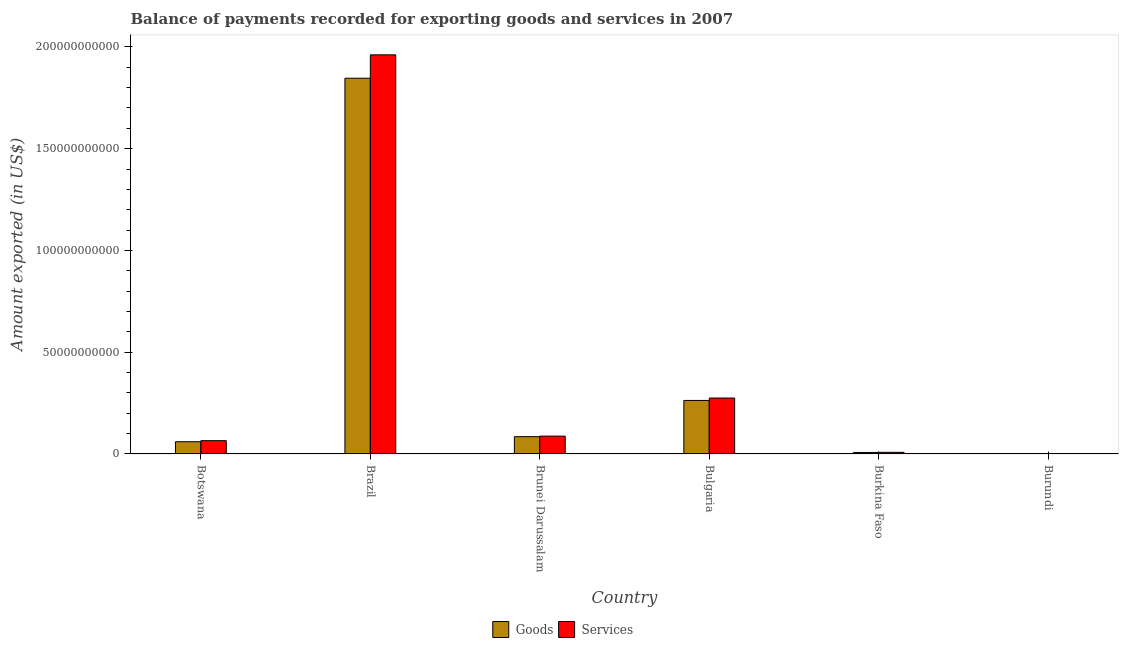How many different coloured bars are there?
Your answer should be very brief. 2. How many groups of bars are there?
Provide a short and direct response. 6. Are the number of bars per tick equal to the number of legend labels?
Keep it short and to the point. Yes. Are the number of bars on each tick of the X-axis equal?
Provide a succinct answer. Yes. In how many cases, is the number of bars for a given country not equal to the number of legend labels?
Make the answer very short. 0. What is the amount of goods exported in Brazil?
Ensure brevity in your answer.  1.85e+11. Across all countries, what is the maximum amount of services exported?
Keep it short and to the point. 1.96e+11. Across all countries, what is the minimum amount of services exported?
Offer a terse response. 9.83e+07. In which country was the amount of goods exported minimum?
Keep it short and to the point. Burundi. What is the total amount of services exported in the graph?
Provide a succinct answer. 2.40e+11. What is the difference between the amount of goods exported in Brunei Darussalam and that in Burkina Faso?
Your response must be concise. 7.76e+09. What is the difference between the amount of goods exported in Brazil and the amount of services exported in Botswana?
Your response must be concise. 1.78e+11. What is the average amount of goods exported per country?
Ensure brevity in your answer.  3.77e+1. What is the difference between the amount of goods exported and amount of services exported in Brazil?
Make the answer very short. -1.15e+1. In how many countries, is the amount of goods exported greater than 170000000000 US$?
Keep it short and to the point. 1. What is the ratio of the amount of goods exported in Botswana to that in Brazil?
Offer a terse response. 0.03. Is the difference between the amount of goods exported in Bulgaria and Burkina Faso greater than the difference between the amount of services exported in Bulgaria and Burkina Faso?
Your answer should be very brief. No. What is the difference between the highest and the second highest amount of goods exported?
Offer a terse response. 1.58e+11. What is the difference between the highest and the lowest amount of goods exported?
Provide a succinct answer. 1.85e+11. Is the sum of the amount of services exported in Botswana and Burkina Faso greater than the maximum amount of goods exported across all countries?
Give a very brief answer. No. What does the 1st bar from the left in Brunei Darussalam represents?
Your answer should be very brief. Goods. What does the 2nd bar from the right in Burundi represents?
Ensure brevity in your answer.  Goods. How many countries are there in the graph?
Offer a terse response. 6. What is the difference between two consecutive major ticks on the Y-axis?
Your answer should be very brief. 5.00e+1. Are the values on the major ticks of Y-axis written in scientific E-notation?
Provide a short and direct response. No. Does the graph contain any zero values?
Your response must be concise. No. How are the legend labels stacked?
Provide a short and direct response. Horizontal. What is the title of the graph?
Offer a very short reply. Balance of payments recorded for exporting goods and services in 2007. Does "Chemicals" appear as one of the legend labels in the graph?
Your answer should be compact. No. What is the label or title of the Y-axis?
Offer a very short reply. Amount exported (in US$). What is the Amount exported (in US$) in Goods in Botswana?
Keep it short and to the point. 6.01e+09. What is the Amount exported (in US$) of Services in Botswana?
Offer a terse response. 6.54e+09. What is the Amount exported (in US$) in Goods in Brazil?
Give a very brief answer. 1.85e+11. What is the Amount exported (in US$) in Services in Brazil?
Offer a terse response. 1.96e+11. What is the Amount exported (in US$) in Goods in Brunei Darussalam?
Provide a succinct answer. 8.50e+09. What is the Amount exported (in US$) of Services in Brunei Darussalam?
Make the answer very short. 8.77e+09. What is the Amount exported (in US$) in Goods in Bulgaria?
Ensure brevity in your answer.  2.63e+1. What is the Amount exported (in US$) in Services in Bulgaria?
Your response must be concise. 2.75e+1. What is the Amount exported (in US$) in Goods in Burkina Faso?
Offer a very short reply. 7.41e+08. What is the Amount exported (in US$) of Services in Burkina Faso?
Offer a terse response. 8.04e+08. What is the Amount exported (in US$) in Goods in Burundi?
Give a very brief answer. 8.96e+07. What is the Amount exported (in US$) of Services in Burundi?
Provide a succinct answer. 9.83e+07. Across all countries, what is the maximum Amount exported (in US$) in Goods?
Your answer should be compact. 1.85e+11. Across all countries, what is the maximum Amount exported (in US$) of Services?
Keep it short and to the point. 1.96e+11. Across all countries, what is the minimum Amount exported (in US$) of Goods?
Your answer should be very brief. 8.96e+07. Across all countries, what is the minimum Amount exported (in US$) of Services?
Ensure brevity in your answer.  9.83e+07. What is the total Amount exported (in US$) of Goods in the graph?
Your response must be concise. 2.26e+11. What is the total Amount exported (in US$) in Services in the graph?
Offer a very short reply. 2.40e+11. What is the difference between the Amount exported (in US$) in Goods in Botswana and that in Brazil?
Offer a very short reply. -1.79e+11. What is the difference between the Amount exported (in US$) in Services in Botswana and that in Brazil?
Ensure brevity in your answer.  -1.90e+11. What is the difference between the Amount exported (in US$) in Goods in Botswana and that in Brunei Darussalam?
Your answer should be compact. -2.49e+09. What is the difference between the Amount exported (in US$) in Services in Botswana and that in Brunei Darussalam?
Your answer should be very brief. -2.24e+09. What is the difference between the Amount exported (in US$) in Goods in Botswana and that in Bulgaria?
Your response must be concise. -2.03e+1. What is the difference between the Amount exported (in US$) of Services in Botswana and that in Bulgaria?
Keep it short and to the point. -2.10e+1. What is the difference between the Amount exported (in US$) in Goods in Botswana and that in Burkina Faso?
Your response must be concise. 5.27e+09. What is the difference between the Amount exported (in US$) of Services in Botswana and that in Burkina Faso?
Make the answer very short. 5.73e+09. What is the difference between the Amount exported (in US$) of Goods in Botswana and that in Burundi?
Give a very brief answer. 5.92e+09. What is the difference between the Amount exported (in US$) in Services in Botswana and that in Burundi?
Your response must be concise. 6.44e+09. What is the difference between the Amount exported (in US$) of Goods in Brazil and that in Brunei Darussalam?
Make the answer very short. 1.76e+11. What is the difference between the Amount exported (in US$) in Services in Brazil and that in Brunei Darussalam?
Your answer should be very brief. 1.87e+11. What is the difference between the Amount exported (in US$) of Goods in Brazil and that in Bulgaria?
Offer a very short reply. 1.58e+11. What is the difference between the Amount exported (in US$) in Services in Brazil and that in Bulgaria?
Keep it short and to the point. 1.69e+11. What is the difference between the Amount exported (in US$) in Goods in Brazil and that in Burkina Faso?
Your answer should be very brief. 1.84e+11. What is the difference between the Amount exported (in US$) of Services in Brazil and that in Burkina Faso?
Provide a short and direct response. 1.95e+11. What is the difference between the Amount exported (in US$) in Goods in Brazil and that in Burundi?
Offer a terse response. 1.85e+11. What is the difference between the Amount exported (in US$) of Services in Brazil and that in Burundi?
Your answer should be very brief. 1.96e+11. What is the difference between the Amount exported (in US$) in Goods in Brunei Darussalam and that in Bulgaria?
Give a very brief answer. -1.78e+1. What is the difference between the Amount exported (in US$) in Services in Brunei Darussalam and that in Bulgaria?
Provide a succinct answer. -1.87e+1. What is the difference between the Amount exported (in US$) in Goods in Brunei Darussalam and that in Burkina Faso?
Make the answer very short. 7.76e+09. What is the difference between the Amount exported (in US$) of Services in Brunei Darussalam and that in Burkina Faso?
Provide a short and direct response. 7.97e+09. What is the difference between the Amount exported (in US$) of Goods in Brunei Darussalam and that in Burundi?
Your answer should be compact. 8.42e+09. What is the difference between the Amount exported (in US$) in Services in Brunei Darussalam and that in Burundi?
Your answer should be very brief. 8.67e+09. What is the difference between the Amount exported (in US$) of Goods in Bulgaria and that in Burkina Faso?
Offer a terse response. 2.56e+1. What is the difference between the Amount exported (in US$) in Services in Bulgaria and that in Burkina Faso?
Provide a short and direct response. 2.67e+1. What is the difference between the Amount exported (in US$) of Goods in Bulgaria and that in Burundi?
Your answer should be compact. 2.62e+1. What is the difference between the Amount exported (in US$) in Services in Bulgaria and that in Burundi?
Offer a very short reply. 2.74e+1. What is the difference between the Amount exported (in US$) of Goods in Burkina Faso and that in Burundi?
Provide a short and direct response. 6.51e+08. What is the difference between the Amount exported (in US$) of Services in Burkina Faso and that in Burundi?
Keep it short and to the point. 7.06e+08. What is the difference between the Amount exported (in US$) of Goods in Botswana and the Amount exported (in US$) of Services in Brazil?
Your answer should be compact. -1.90e+11. What is the difference between the Amount exported (in US$) in Goods in Botswana and the Amount exported (in US$) in Services in Brunei Darussalam?
Offer a terse response. -2.76e+09. What is the difference between the Amount exported (in US$) of Goods in Botswana and the Amount exported (in US$) of Services in Bulgaria?
Keep it short and to the point. -2.15e+1. What is the difference between the Amount exported (in US$) in Goods in Botswana and the Amount exported (in US$) in Services in Burkina Faso?
Make the answer very short. 5.21e+09. What is the difference between the Amount exported (in US$) in Goods in Botswana and the Amount exported (in US$) in Services in Burundi?
Your response must be concise. 5.91e+09. What is the difference between the Amount exported (in US$) in Goods in Brazil and the Amount exported (in US$) in Services in Brunei Darussalam?
Your answer should be very brief. 1.76e+11. What is the difference between the Amount exported (in US$) of Goods in Brazil and the Amount exported (in US$) of Services in Bulgaria?
Provide a succinct answer. 1.57e+11. What is the difference between the Amount exported (in US$) in Goods in Brazil and the Amount exported (in US$) in Services in Burkina Faso?
Offer a very short reply. 1.84e+11. What is the difference between the Amount exported (in US$) in Goods in Brazil and the Amount exported (in US$) in Services in Burundi?
Give a very brief answer. 1.85e+11. What is the difference between the Amount exported (in US$) of Goods in Brunei Darussalam and the Amount exported (in US$) of Services in Bulgaria?
Make the answer very short. -1.90e+1. What is the difference between the Amount exported (in US$) of Goods in Brunei Darussalam and the Amount exported (in US$) of Services in Burkina Faso?
Give a very brief answer. 7.70e+09. What is the difference between the Amount exported (in US$) of Goods in Brunei Darussalam and the Amount exported (in US$) of Services in Burundi?
Ensure brevity in your answer.  8.41e+09. What is the difference between the Amount exported (in US$) in Goods in Bulgaria and the Amount exported (in US$) in Services in Burkina Faso?
Keep it short and to the point. 2.55e+1. What is the difference between the Amount exported (in US$) of Goods in Bulgaria and the Amount exported (in US$) of Services in Burundi?
Give a very brief answer. 2.62e+1. What is the difference between the Amount exported (in US$) of Goods in Burkina Faso and the Amount exported (in US$) of Services in Burundi?
Provide a short and direct response. 6.42e+08. What is the average Amount exported (in US$) of Goods per country?
Offer a terse response. 3.77e+1. What is the average Amount exported (in US$) of Services per country?
Offer a terse response. 4.00e+1. What is the difference between the Amount exported (in US$) of Goods and Amount exported (in US$) of Services in Botswana?
Make the answer very short. -5.24e+08. What is the difference between the Amount exported (in US$) in Goods and Amount exported (in US$) in Services in Brazil?
Your answer should be compact. -1.15e+1. What is the difference between the Amount exported (in US$) in Goods and Amount exported (in US$) in Services in Brunei Darussalam?
Make the answer very short. -2.68e+08. What is the difference between the Amount exported (in US$) in Goods and Amount exported (in US$) in Services in Bulgaria?
Your response must be concise. -1.19e+09. What is the difference between the Amount exported (in US$) in Goods and Amount exported (in US$) in Services in Burkina Faso?
Offer a very short reply. -6.34e+07. What is the difference between the Amount exported (in US$) of Goods and Amount exported (in US$) of Services in Burundi?
Offer a very short reply. -8.67e+06. What is the ratio of the Amount exported (in US$) in Goods in Botswana to that in Brazil?
Provide a succinct answer. 0.03. What is the ratio of the Amount exported (in US$) of Goods in Botswana to that in Brunei Darussalam?
Offer a very short reply. 0.71. What is the ratio of the Amount exported (in US$) in Services in Botswana to that in Brunei Darussalam?
Your answer should be compact. 0.74. What is the ratio of the Amount exported (in US$) in Goods in Botswana to that in Bulgaria?
Your response must be concise. 0.23. What is the ratio of the Amount exported (in US$) in Services in Botswana to that in Bulgaria?
Your answer should be very brief. 0.24. What is the ratio of the Amount exported (in US$) in Goods in Botswana to that in Burkina Faso?
Offer a very short reply. 8.12. What is the ratio of the Amount exported (in US$) in Services in Botswana to that in Burkina Faso?
Your answer should be compact. 8.13. What is the ratio of the Amount exported (in US$) of Goods in Botswana to that in Burundi?
Your response must be concise. 67.07. What is the ratio of the Amount exported (in US$) in Services in Botswana to that in Burundi?
Your response must be concise. 66.49. What is the ratio of the Amount exported (in US$) of Goods in Brazil to that in Brunei Darussalam?
Offer a terse response. 21.71. What is the ratio of the Amount exported (in US$) of Services in Brazil to that in Brunei Darussalam?
Offer a terse response. 22.35. What is the ratio of the Amount exported (in US$) in Goods in Brazil to that in Bulgaria?
Your answer should be compact. 7.02. What is the ratio of the Amount exported (in US$) of Services in Brazil to that in Bulgaria?
Give a very brief answer. 7.13. What is the ratio of the Amount exported (in US$) in Goods in Brazil to that in Burkina Faso?
Make the answer very short. 249.27. What is the ratio of the Amount exported (in US$) in Services in Brazil to that in Burkina Faso?
Your answer should be compact. 243.92. What is the ratio of the Amount exported (in US$) of Goods in Brazil to that in Burundi?
Keep it short and to the point. 2059.58. What is the ratio of the Amount exported (in US$) in Services in Brazil to that in Burundi?
Your answer should be very brief. 1994.85. What is the ratio of the Amount exported (in US$) in Goods in Brunei Darussalam to that in Bulgaria?
Provide a short and direct response. 0.32. What is the ratio of the Amount exported (in US$) of Services in Brunei Darussalam to that in Bulgaria?
Your answer should be very brief. 0.32. What is the ratio of the Amount exported (in US$) of Goods in Brunei Darussalam to that in Burkina Faso?
Your response must be concise. 11.48. What is the ratio of the Amount exported (in US$) of Services in Brunei Darussalam to that in Burkina Faso?
Provide a short and direct response. 10.91. What is the ratio of the Amount exported (in US$) in Goods in Brunei Darussalam to that in Burundi?
Provide a short and direct response. 94.89. What is the ratio of the Amount exported (in US$) in Services in Brunei Darussalam to that in Burundi?
Give a very brief answer. 89.25. What is the ratio of the Amount exported (in US$) in Goods in Bulgaria to that in Burkina Faso?
Your answer should be compact. 35.51. What is the ratio of the Amount exported (in US$) of Services in Bulgaria to that in Burkina Faso?
Ensure brevity in your answer.  34.19. What is the ratio of the Amount exported (in US$) of Goods in Bulgaria to that in Burundi?
Your answer should be compact. 293.4. What is the ratio of the Amount exported (in US$) of Services in Bulgaria to that in Burundi?
Offer a very short reply. 279.63. What is the ratio of the Amount exported (in US$) of Goods in Burkina Faso to that in Burundi?
Provide a succinct answer. 8.26. What is the ratio of the Amount exported (in US$) in Services in Burkina Faso to that in Burundi?
Make the answer very short. 8.18. What is the difference between the highest and the second highest Amount exported (in US$) of Goods?
Your answer should be compact. 1.58e+11. What is the difference between the highest and the second highest Amount exported (in US$) in Services?
Keep it short and to the point. 1.69e+11. What is the difference between the highest and the lowest Amount exported (in US$) of Goods?
Your response must be concise. 1.85e+11. What is the difference between the highest and the lowest Amount exported (in US$) in Services?
Your answer should be very brief. 1.96e+11. 